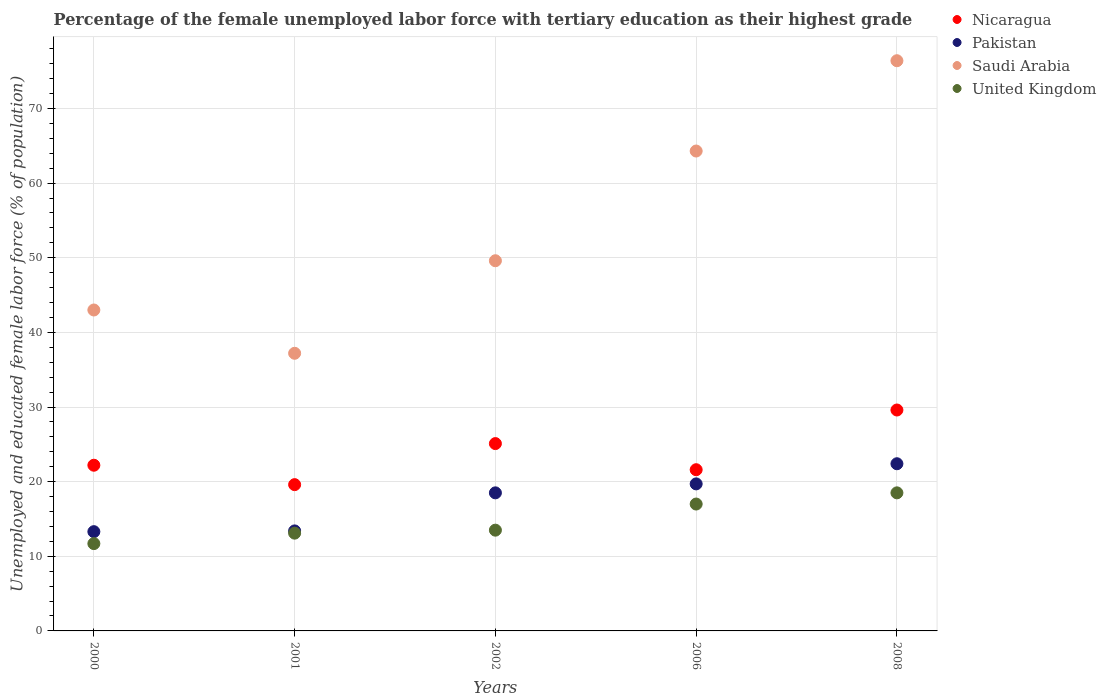How many different coloured dotlines are there?
Make the answer very short. 4. What is the percentage of the unemployed female labor force with tertiary education in Pakistan in 2002?
Your answer should be compact. 18.5. Across all years, what is the maximum percentage of the unemployed female labor force with tertiary education in Nicaragua?
Offer a terse response. 29.6. Across all years, what is the minimum percentage of the unemployed female labor force with tertiary education in Saudi Arabia?
Ensure brevity in your answer.  37.2. In which year was the percentage of the unemployed female labor force with tertiary education in Saudi Arabia maximum?
Give a very brief answer. 2008. What is the total percentage of the unemployed female labor force with tertiary education in United Kingdom in the graph?
Ensure brevity in your answer.  73.8. What is the difference between the percentage of the unemployed female labor force with tertiary education in Nicaragua in 2000 and that in 2002?
Your answer should be compact. -2.9. What is the difference between the percentage of the unemployed female labor force with tertiary education in United Kingdom in 2001 and the percentage of the unemployed female labor force with tertiary education in Saudi Arabia in 2000?
Make the answer very short. -29.9. What is the average percentage of the unemployed female labor force with tertiary education in Pakistan per year?
Offer a very short reply. 17.46. In the year 2000, what is the difference between the percentage of the unemployed female labor force with tertiary education in Saudi Arabia and percentage of the unemployed female labor force with tertiary education in Nicaragua?
Your answer should be compact. 20.8. In how many years, is the percentage of the unemployed female labor force with tertiary education in Saudi Arabia greater than 4 %?
Offer a terse response. 5. What is the ratio of the percentage of the unemployed female labor force with tertiary education in Nicaragua in 2006 to that in 2008?
Your answer should be compact. 0.73. Is the difference between the percentage of the unemployed female labor force with tertiary education in Saudi Arabia in 2002 and 2006 greater than the difference between the percentage of the unemployed female labor force with tertiary education in Nicaragua in 2002 and 2006?
Your answer should be very brief. No. What is the difference between the highest and the second highest percentage of the unemployed female labor force with tertiary education in Pakistan?
Keep it short and to the point. 2.7. What is the difference between the highest and the lowest percentage of the unemployed female labor force with tertiary education in Saudi Arabia?
Your response must be concise. 39.2. In how many years, is the percentage of the unemployed female labor force with tertiary education in Pakistan greater than the average percentage of the unemployed female labor force with tertiary education in Pakistan taken over all years?
Your answer should be very brief. 3. Is the sum of the percentage of the unemployed female labor force with tertiary education in United Kingdom in 2001 and 2008 greater than the maximum percentage of the unemployed female labor force with tertiary education in Pakistan across all years?
Make the answer very short. Yes. Is it the case that in every year, the sum of the percentage of the unemployed female labor force with tertiary education in Nicaragua and percentage of the unemployed female labor force with tertiary education in United Kingdom  is greater than the sum of percentage of the unemployed female labor force with tertiary education in Pakistan and percentage of the unemployed female labor force with tertiary education in Saudi Arabia?
Ensure brevity in your answer.  No. Is it the case that in every year, the sum of the percentage of the unemployed female labor force with tertiary education in Pakistan and percentage of the unemployed female labor force with tertiary education in Saudi Arabia  is greater than the percentage of the unemployed female labor force with tertiary education in United Kingdom?
Provide a short and direct response. Yes. Is the percentage of the unemployed female labor force with tertiary education in Pakistan strictly greater than the percentage of the unemployed female labor force with tertiary education in Nicaragua over the years?
Provide a short and direct response. No. Is the percentage of the unemployed female labor force with tertiary education in Saudi Arabia strictly less than the percentage of the unemployed female labor force with tertiary education in United Kingdom over the years?
Provide a short and direct response. No. How many dotlines are there?
Provide a succinct answer. 4. What is the difference between two consecutive major ticks on the Y-axis?
Ensure brevity in your answer.  10. Are the values on the major ticks of Y-axis written in scientific E-notation?
Keep it short and to the point. No. How are the legend labels stacked?
Provide a short and direct response. Vertical. What is the title of the graph?
Ensure brevity in your answer.  Percentage of the female unemployed labor force with tertiary education as their highest grade. What is the label or title of the X-axis?
Your answer should be compact. Years. What is the label or title of the Y-axis?
Your response must be concise. Unemployed and educated female labor force (% of population). What is the Unemployed and educated female labor force (% of population) in Nicaragua in 2000?
Provide a short and direct response. 22.2. What is the Unemployed and educated female labor force (% of population) of Pakistan in 2000?
Offer a terse response. 13.3. What is the Unemployed and educated female labor force (% of population) in United Kingdom in 2000?
Make the answer very short. 11.7. What is the Unemployed and educated female labor force (% of population) of Nicaragua in 2001?
Offer a very short reply. 19.6. What is the Unemployed and educated female labor force (% of population) of Pakistan in 2001?
Your answer should be very brief. 13.4. What is the Unemployed and educated female labor force (% of population) of Saudi Arabia in 2001?
Provide a succinct answer. 37.2. What is the Unemployed and educated female labor force (% of population) of United Kingdom in 2001?
Make the answer very short. 13.1. What is the Unemployed and educated female labor force (% of population) in Nicaragua in 2002?
Your answer should be compact. 25.1. What is the Unemployed and educated female labor force (% of population) of Saudi Arabia in 2002?
Your answer should be very brief. 49.6. What is the Unemployed and educated female labor force (% of population) of United Kingdom in 2002?
Provide a succinct answer. 13.5. What is the Unemployed and educated female labor force (% of population) in Nicaragua in 2006?
Offer a terse response. 21.6. What is the Unemployed and educated female labor force (% of population) in Pakistan in 2006?
Ensure brevity in your answer.  19.7. What is the Unemployed and educated female labor force (% of population) in Saudi Arabia in 2006?
Keep it short and to the point. 64.3. What is the Unemployed and educated female labor force (% of population) in Nicaragua in 2008?
Offer a terse response. 29.6. What is the Unemployed and educated female labor force (% of population) in Pakistan in 2008?
Your response must be concise. 22.4. What is the Unemployed and educated female labor force (% of population) of Saudi Arabia in 2008?
Your answer should be compact. 76.4. What is the Unemployed and educated female labor force (% of population) in United Kingdom in 2008?
Ensure brevity in your answer.  18.5. Across all years, what is the maximum Unemployed and educated female labor force (% of population) in Nicaragua?
Provide a succinct answer. 29.6. Across all years, what is the maximum Unemployed and educated female labor force (% of population) in Pakistan?
Provide a short and direct response. 22.4. Across all years, what is the maximum Unemployed and educated female labor force (% of population) of Saudi Arabia?
Offer a terse response. 76.4. Across all years, what is the maximum Unemployed and educated female labor force (% of population) in United Kingdom?
Give a very brief answer. 18.5. Across all years, what is the minimum Unemployed and educated female labor force (% of population) of Nicaragua?
Offer a terse response. 19.6. Across all years, what is the minimum Unemployed and educated female labor force (% of population) in Pakistan?
Make the answer very short. 13.3. Across all years, what is the minimum Unemployed and educated female labor force (% of population) of Saudi Arabia?
Give a very brief answer. 37.2. Across all years, what is the minimum Unemployed and educated female labor force (% of population) in United Kingdom?
Provide a short and direct response. 11.7. What is the total Unemployed and educated female labor force (% of population) in Nicaragua in the graph?
Your answer should be very brief. 118.1. What is the total Unemployed and educated female labor force (% of population) in Pakistan in the graph?
Keep it short and to the point. 87.3. What is the total Unemployed and educated female labor force (% of population) in Saudi Arabia in the graph?
Offer a terse response. 270.5. What is the total Unemployed and educated female labor force (% of population) in United Kingdom in the graph?
Offer a very short reply. 73.8. What is the difference between the Unemployed and educated female labor force (% of population) in Nicaragua in 2000 and that in 2001?
Your response must be concise. 2.6. What is the difference between the Unemployed and educated female labor force (% of population) in Pakistan in 2000 and that in 2001?
Offer a very short reply. -0.1. What is the difference between the Unemployed and educated female labor force (% of population) of Saudi Arabia in 2000 and that in 2001?
Provide a short and direct response. 5.8. What is the difference between the Unemployed and educated female labor force (% of population) in Nicaragua in 2000 and that in 2002?
Give a very brief answer. -2.9. What is the difference between the Unemployed and educated female labor force (% of population) of Saudi Arabia in 2000 and that in 2002?
Provide a succinct answer. -6.6. What is the difference between the Unemployed and educated female labor force (% of population) of United Kingdom in 2000 and that in 2002?
Make the answer very short. -1.8. What is the difference between the Unemployed and educated female labor force (% of population) of Saudi Arabia in 2000 and that in 2006?
Provide a succinct answer. -21.3. What is the difference between the Unemployed and educated female labor force (% of population) in Nicaragua in 2000 and that in 2008?
Ensure brevity in your answer.  -7.4. What is the difference between the Unemployed and educated female labor force (% of population) of Saudi Arabia in 2000 and that in 2008?
Make the answer very short. -33.4. What is the difference between the Unemployed and educated female labor force (% of population) of Pakistan in 2001 and that in 2002?
Keep it short and to the point. -5.1. What is the difference between the Unemployed and educated female labor force (% of population) in Pakistan in 2001 and that in 2006?
Provide a short and direct response. -6.3. What is the difference between the Unemployed and educated female labor force (% of population) in Saudi Arabia in 2001 and that in 2006?
Give a very brief answer. -27.1. What is the difference between the Unemployed and educated female labor force (% of population) of Pakistan in 2001 and that in 2008?
Provide a succinct answer. -9. What is the difference between the Unemployed and educated female labor force (% of population) of Saudi Arabia in 2001 and that in 2008?
Your response must be concise. -39.2. What is the difference between the Unemployed and educated female labor force (% of population) in Nicaragua in 2002 and that in 2006?
Your answer should be very brief. 3.5. What is the difference between the Unemployed and educated female labor force (% of population) of Pakistan in 2002 and that in 2006?
Give a very brief answer. -1.2. What is the difference between the Unemployed and educated female labor force (% of population) of Saudi Arabia in 2002 and that in 2006?
Your response must be concise. -14.7. What is the difference between the Unemployed and educated female labor force (% of population) of Nicaragua in 2002 and that in 2008?
Provide a succinct answer. -4.5. What is the difference between the Unemployed and educated female labor force (% of population) of Saudi Arabia in 2002 and that in 2008?
Offer a very short reply. -26.8. What is the difference between the Unemployed and educated female labor force (% of population) in Nicaragua in 2000 and the Unemployed and educated female labor force (% of population) in Pakistan in 2001?
Make the answer very short. 8.8. What is the difference between the Unemployed and educated female labor force (% of population) of Nicaragua in 2000 and the Unemployed and educated female labor force (% of population) of United Kingdom in 2001?
Provide a succinct answer. 9.1. What is the difference between the Unemployed and educated female labor force (% of population) of Pakistan in 2000 and the Unemployed and educated female labor force (% of population) of Saudi Arabia in 2001?
Offer a very short reply. -23.9. What is the difference between the Unemployed and educated female labor force (% of population) in Pakistan in 2000 and the Unemployed and educated female labor force (% of population) in United Kingdom in 2001?
Your answer should be very brief. 0.2. What is the difference between the Unemployed and educated female labor force (% of population) in Saudi Arabia in 2000 and the Unemployed and educated female labor force (% of population) in United Kingdom in 2001?
Keep it short and to the point. 29.9. What is the difference between the Unemployed and educated female labor force (% of population) in Nicaragua in 2000 and the Unemployed and educated female labor force (% of population) in Saudi Arabia in 2002?
Provide a succinct answer. -27.4. What is the difference between the Unemployed and educated female labor force (% of population) in Nicaragua in 2000 and the Unemployed and educated female labor force (% of population) in United Kingdom in 2002?
Make the answer very short. 8.7. What is the difference between the Unemployed and educated female labor force (% of population) of Pakistan in 2000 and the Unemployed and educated female labor force (% of population) of Saudi Arabia in 2002?
Ensure brevity in your answer.  -36.3. What is the difference between the Unemployed and educated female labor force (% of population) of Pakistan in 2000 and the Unemployed and educated female labor force (% of population) of United Kingdom in 2002?
Offer a terse response. -0.2. What is the difference between the Unemployed and educated female labor force (% of population) of Saudi Arabia in 2000 and the Unemployed and educated female labor force (% of population) of United Kingdom in 2002?
Keep it short and to the point. 29.5. What is the difference between the Unemployed and educated female labor force (% of population) of Nicaragua in 2000 and the Unemployed and educated female labor force (% of population) of Saudi Arabia in 2006?
Offer a very short reply. -42.1. What is the difference between the Unemployed and educated female labor force (% of population) of Nicaragua in 2000 and the Unemployed and educated female labor force (% of population) of United Kingdom in 2006?
Make the answer very short. 5.2. What is the difference between the Unemployed and educated female labor force (% of population) of Pakistan in 2000 and the Unemployed and educated female labor force (% of population) of Saudi Arabia in 2006?
Your answer should be very brief. -51. What is the difference between the Unemployed and educated female labor force (% of population) of Nicaragua in 2000 and the Unemployed and educated female labor force (% of population) of Saudi Arabia in 2008?
Keep it short and to the point. -54.2. What is the difference between the Unemployed and educated female labor force (% of population) of Nicaragua in 2000 and the Unemployed and educated female labor force (% of population) of United Kingdom in 2008?
Make the answer very short. 3.7. What is the difference between the Unemployed and educated female labor force (% of population) in Pakistan in 2000 and the Unemployed and educated female labor force (% of population) in Saudi Arabia in 2008?
Offer a terse response. -63.1. What is the difference between the Unemployed and educated female labor force (% of population) of Saudi Arabia in 2000 and the Unemployed and educated female labor force (% of population) of United Kingdom in 2008?
Your response must be concise. 24.5. What is the difference between the Unemployed and educated female labor force (% of population) of Nicaragua in 2001 and the Unemployed and educated female labor force (% of population) of Saudi Arabia in 2002?
Ensure brevity in your answer.  -30. What is the difference between the Unemployed and educated female labor force (% of population) in Nicaragua in 2001 and the Unemployed and educated female labor force (% of population) in United Kingdom in 2002?
Offer a terse response. 6.1. What is the difference between the Unemployed and educated female labor force (% of population) in Pakistan in 2001 and the Unemployed and educated female labor force (% of population) in Saudi Arabia in 2002?
Give a very brief answer. -36.2. What is the difference between the Unemployed and educated female labor force (% of population) of Saudi Arabia in 2001 and the Unemployed and educated female labor force (% of population) of United Kingdom in 2002?
Give a very brief answer. 23.7. What is the difference between the Unemployed and educated female labor force (% of population) of Nicaragua in 2001 and the Unemployed and educated female labor force (% of population) of Pakistan in 2006?
Your response must be concise. -0.1. What is the difference between the Unemployed and educated female labor force (% of population) of Nicaragua in 2001 and the Unemployed and educated female labor force (% of population) of Saudi Arabia in 2006?
Your answer should be very brief. -44.7. What is the difference between the Unemployed and educated female labor force (% of population) of Pakistan in 2001 and the Unemployed and educated female labor force (% of population) of Saudi Arabia in 2006?
Your answer should be compact. -50.9. What is the difference between the Unemployed and educated female labor force (% of population) in Pakistan in 2001 and the Unemployed and educated female labor force (% of population) in United Kingdom in 2006?
Your answer should be very brief. -3.6. What is the difference between the Unemployed and educated female labor force (% of population) in Saudi Arabia in 2001 and the Unemployed and educated female labor force (% of population) in United Kingdom in 2006?
Provide a short and direct response. 20.2. What is the difference between the Unemployed and educated female labor force (% of population) in Nicaragua in 2001 and the Unemployed and educated female labor force (% of population) in Saudi Arabia in 2008?
Provide a short and direct response. -56.8. What is the difference between the Unemployed and educated female labor force (% of population) of Pakistan in 2001 and the Unemployed and educated female labor force (% of population) of Saudi Arabia in 2008?
Offer a very short reply. -63. What is the difference between the Unemployed and educated female labor force (% of population) in Nicaragua in 2002 and the Unemployed and educated female labor force (% of population) in Saudi Arabia in 2006?
Provide a succinct answer. -39.2. What is the difference between the Unemployed and educated female labor force (% of population) of Pakistan in 2002 and the Unemployed and educated female labor force (% of population) of Saudi Arabia in 2006?
Ensure brevity in your answer.  -45.8. What is the difference between the Unemployed and educated female labor force (% of population) of Saudi Arabia in 2002 and the Unemployed and educated female labor force (% of population) of United Kingdom in 2006?
Make the answer very short. 32.6. What is the difference between the Unemployed and educated female labor force (% of population) in Nicaragua in 2002 and the Unemployed and educated female labor force (% of population) in Saudi Arabia in 2008?
Offer a very short reply. -51.3. What is the difference between the Unemployed and educated female labor force (% of population) of Nicaragua in 2002 and the Unemployed and educated female labor force (% of population) of United Kingdom in 2008?
Offer a very short reply. 6.6. What is the difference between the Unemployed and educated female labor force (% of population) of Pakistan in 2002 and the Unemployed and educated female labor force (% of population) of Saudi Arabia in 2008?
Offer a very short reply. -57.9. What is the difference between the Unemployed and educated female labor force (% of population) in Pakistan in 2002 and the Unemployed and educated female labor force (% of population) in United Kingdom in 2008?
Keep it short and to the point. 0. What is the difference between the Unemployed and educated female labor force (% of population) of Saudi Arabia in 2002 and the Unemployed and educated female labor force (% of population) of United Kingdom in 2008?
Offer a terse response. 31.1. What is the difference between the Unemployed and educated female labor force (% of population) of Nicaragua in 2006 and the Unemployed and educated female labor force (% of population) of Pakistan in 2008?
Keep it short and to the point. -0.8. What is the difference between the Unemployed and educated female labor force (% of population) in Nicaragua in 2006 and the Unemployed and educated female labor force (% of population) in Saudi Arabia in 2008?
Your answer should be compact. -54.8. What is the difference between the Unemployed and educated female labor force (% of population) in Pakistan in 2006 and the Unemployed and educated female labor force (% of population) in Saudi Arabia in 2008?
Give a very brief answer. -56.7. What is the difference between the Unemployed and educated female labor force (% of population) of Pakistan in 2006 and the Unemployed and educated female labor force (% of population) of United Kingdom in 2008?
Provide a short and direct response. 1.2. What is the difference between the Unemployed and educated female labor force (% of population) of Saudi Arabia in 2006 and the Unemployed and educated female labor force (% of population) of United Kingdom in 2008?
Offer a very short reply. 45.8. What is the average Unemployed and educated female labor force (% of population) in Nicaragua per year?
Your answer should be very brief. 23.62. What is the average Unemployed and educated female labor force (% of population) of Pakistan per year?
Give a very brief answer. 17.46. What is the average Unemployed and educated female labor force (% of population) in Saudi Arabia per year?
Your answer should be compact. 54.1. What is the average Unemployed and educated female labor force (% of population) of United Kingdom per year?
Offer a very short reply. 14.76. In the year 2000, what is the difference between the Unemployed and educated female labor force (% of population) of Nicaragua and Unemployed and educated female labor force (% of population) of Pakistan?
Ensure brevity in your answer.  8.9. In the year 2000, what is the difference between the Unemployed and educated female labor force (% of population) in Nicaragua and Unemployed and educated female labor force (% of population) in Saudi Arabia?
Offer a very short reply. -20.8. In the year 2000, what is the difference between the Unemployed and educated female labor force (% of population) in Nicaragua and Unemployed and educated female labor force (% of population) in United Kingdom?
Keep it short and to the point. 10.5. In the year 2000, what is the difference between the Unemployed and educated female labor force (% of population) in Pakistan and Unemployed and educated female labor force (% of population) in Saudi Arabia?
Your answer should be compact. -29.7. In the year 2000, what is the difference between the Unemployed and educated female labor force (% of population) of Saudi Arabia and Unemployed and educated female labor force (% of population) of United Kingdom?
Keep it short and to the point. 31.3. In the year 2001, what is the difference between the Unemployed and educated female labor force (% of population) in Nicaragua and Unemployed and educated female labor force (% of population) in Pakistan?
Your response must be concise. 6.2. In the year 2001, what is the difference between the Unemployed and educated female labor force (% of population) of Nicaragua and Unemployed and educated female labor force (% of population) of Saudi Arabia?
Ensure brevity in your answer.  -17.6. In the year 2001, what is the difference between the Unemployed and educated female labor force (% of population) in Pakistan and Unemployed and educated female labor force (% of population) in Saudi Arabia?
Provide a short and direct response. -23.8. In the year 2001, what is the difference between the Unemployed and educated female labor force (% of population) of Saudi Arabia and Unemployed and educated female labor force (% of population) of United Kingdom?
Ensure brevity in your answer.  24.1. In the year 2002, what is the difference between the Unemployed and educated female labor force (% of population) of Nicaragua and Unemployed and educated female labor force (% of population) of Saudi Arabia?
Your response must be concise. -24.5. In the year 2002, what is the difference between the Unemployed and educated female labor force (% of population) in Nicaragua and Unemployed and educated female labor force (% of population) in United Kingdom?
Offer a terse response. 11.6. In the year 2002, what is the difference between the Unemployed and educated female labor force (% of population) in Pakistan and Unemployed and educated female labor force (% of population) in Saudi Arabia?
Your answer should be very brief. -31.1. In the year 2002, what is the difference between the Unemployed and educated female labor force (% of population) of Pakistan and Unemployed and educated female labor force (% of population) of United Kingdom?
Provide a succinct answer. 5. In the year 2002, what is the difference between the Unemployed and educated female labor force (% of population) of Saudi Arabia and Unemployed and educated female labor force (% of population) of United Kingdom?
Offer a very short reply. 36.1. In the year 2006, what is the difference between the Unemployed and educated female labor force (% of population) of Nicaragua and Unemployed and educated female labor force (% of population) of Saudi Arabia?
Give a very brief answer. -42.7. In the year 2006, what is the difference between the Unemployed and educated female labor force (% of population) in Pakistan and Unemployed and educated female labor force (% of population) in Saudi Arabia?
Your answer should be very brief. -44.6. In the year 2006, what is the difference between the Unemployed and educated female labor force (% of population) in Pakistan and Unemployed and educated female labor force (% of population) in United Kingdom?
Offer a very short reply. 2.7. In the year 2006, what is the difference between the Unemployed and educated female labor force (% of population) of Saudi Arabia and Unemployed and educated female labor force (% of population) of United Kingdom?
Keep it short and to the point. 47.3. In the year 2008, what is the difference between the Unemployed and educated female labor force (% of population) in Nicaragua and Unemployed and educated female labor force (% of population) in Pakistan?
Your response must be concise. 7.2. In the year 2008, what is the difference between the Unemployed and educated female labor force (% of population) of Nicaragua and Unemployed and educated female labor force (% of population) of Saudi Arabia?
Offer a very short reply. -46.8. In the year 2008, what is the difference between the Unemployed and educated female labor force (% of population) of Nicaragua and Unemployed and educated female labor force (% of population) of United Kingdom?
Offer a very short reply. 11.1. In the year 2008, what is the difference between the Unemployed and educated female labor force (% of population) in Pakistan and Unemployed and educated female labor force (% of population) in Saudi Arabia?
Make the answer very short. -54. In the year 2008, what is the difference between the Unemployed and educated female labor force (% of population) in Pakistan and Unemployed and educated female labor force (% of population) in United Kingdom?
Keep it short and to the point. 3.9. In the year 2008, what is the difference between the Unemployed and educated female labor force (% of population) of Saudi Arabia and Unemployed and educated female labor force (% of population) of United Kingdom?
Provide a succinct answer. 57.9. What is the ratio of the Unemployed and educated female labor force (% of population) of Nicaragua in 2000 to that in 2001?
Keep it short and to the point. 1.13. What is the ratio of the Unemployed and educated female labor force (% of population) in Pakistan in 2000 to that in 2001?
Ensure brevity in your answer.  0.99. What is the ratio of the Unemployed and educated female labor force (% of population) of Saudi Arabia in 2000 to that in 2001?
Your answer should be very brief. 1.16. What is the ratio of the Unemployed and educated female labor force (% of population) in United Kingdom in 2000 to that in 2001?
Give a very brief answer. 0.89. What is the ratio of the Unemployed and educated female labor force (% of population) in Nicaragua in 2000 to that in 2002?
Make the answer very short. 0.88. What is the ratio of the Unemployed and educated female labor force (% of population) of Pakistan in 2000 to that in 2002?
Your answer should be compact. 0.72. What is the ratio of the Unemployed and educated female labor force (% of population) in Saudi Arabia in 2000 to that in 2002?
Provide a succinct answer. 0.87. What is the ratio of the Unemployed and educated female labor force (% of population) in United Kingdom in 2000 to that in 2002?
Offer a terse response. 0.87. What is the ratio of the Unemployed and educated female labor force (% of population) in Nicaragua in 2000 to that in 2006?
Provide a short and direct response. 1.03. What is the ratio of the Unemployed and educated female labor force (% of population) of Pakistan in 2000 to that in 2006?
Ensure brevity in your answer.  0.68. What is the ratio of the Unemployed and educated female labor force (% of population) of Saudi Arabia in 2000 to that in 2006?
Give a very brief answer. 0.67. What is the ratio of the Unemployed and educated female labor force (% of population) in United Kingdom in 2000 to that in 2006?
Make the answer very short. 0.69. What is the ratio of the Unemployed and educated female labor force (% of population) of Nicaragua in 2000 to that in 2008?
Offer a very short reply. 0.75. What is the ratio of the Unemployed and educated female labor force (% of population) in Pakistan in 2000 to that in 2008?
Your answer should be compact. 0.59. What is the ratio of the Unemployed and educated female labor force (% of population) in Saudi Arabia in 2000 to that in 2008?
Provide a succinct answer. 0.56. What is the ratio of the Unemployed and educated female labor force (% of population) in United Kingdom in 2000 to that in 2008?
Provide a short and direct response. 0.63. What is the ratio of the Unemployed and educated female labor force (% of population) in Nicaragua in 2001 to that in 2002?
Make the answer very short. 0.78. What is the ratio of the Unemployed and educated female labor force (% of population) of Pakistan in 2001 to that in 2002?
Offer a very short reply. 0.72. What is the ratio of the Unemployed and educated female labor force (% of population) in Saudi Arabia in 2001 to that in 2002?
Your answer should be compact. 0.75. What is the ratio of the Unemployed and educated female labor force (% of population) of United Kingdom in 2001 to that in 2002?
Your answer should be compact. 0.97. What is the ratio of the Unemployed and educated female labor force (% of population) of Nicaragua in 2001 to that in 2006?
Your answer should be compact. 0.91. What is the ratio of the Unemployed and educated female labor force (% of population) of Pakistan in 2001 to that in 2006?
Make the answer very short. 0.68. What is the ratio of the Unemployed and educated female labor force (% of population) in Saudi Arabia in 2001 to that in 2006?
Provide a short and direct response. 0.58. What is the ratio of the Unemployed and educated female labor force (% of population) in United Kingdom in 2001 to that in 2006?
Make the answer very short. 0.77. What is the ratio of the Unemployed and educated female labor force (% of population) of Nicaragua in 2001 to that in 2008?
Your answer should be very brief. 0.66. What is the ratio of the Unemployed and educated female labor force (% of population) of Pakistan in 2001 to that in 2008?
Your answer should be compact. 0.6. What is the ratio of the Unemployed and educated female labor force (% of population) in Saudi Arabia in 2001 to that in 2008?
Offer a very short reply. 0.49. What is the ratio of the Unemployed and educated female labor force (% of population) of United Kingdom in 2001 to that in 2008?
Your response must be concise. 0.71. What is the ratio of the Unemployed and educated female labor force (% of population) of Nicaragua in 2002 to that in 2006?
Offer a terse response. 1.16. What is the ratio of the Unemployed and educated female labor force (% of population) of Pakistan in 2002 to that in 2006?
Provide a succinct answer. 0.94. What is the ratio of the Unemployed and educated female labor force (% of population) in Saudi Arabia in 2002 to that in 2006?
Your response must be concise. 0.77. What is the ratio of the Unemployed and educated female labor force (% of population) in United Kingdom in 2002 to that in 2006?
Give a very brief answer. 0.79. What is the ratio of the Unemployed and educated female labor force (% of population) of Nicaragua in 2002 to that in 2008?
Provide a succinct answer. 0.85. What is the ratio of the Unemployed and educated female labor force (% of population) in Pakistan in 2002 to that in 2008?
Give a very brief answer. 0.83. What is the ratio of the Unemployed and educated female labor force (% of population) in Saudi Arabia in 2002 to that in 2008?
Make the answer very short. 0.65. What is the ratio of the Unemployed and educated female labor force (% of population) of United Kingdom in 2002 to that in 2008?
Keep it short and to the point. 0.73. What is the ratio of the Unemployed and educated female labor force (% of population) in Nicaragua in 2006 to that in 2008?
Your answer should be compact. 0.73. What is the ratio of the Unemployed and educated female labor force (% of population) in Pakistan in 2006 to that in 2008?
Your response must be concise. 0.88. What is the ratio of the Unemployed and educated female labor force (% of population) of Saudi Arabia in 2006 to that in 2008?
Your answer should be very brief. 0.84. What is the ratio of the Unemployed and educated female labor force (% of population) in United Kingdom in 2006 to that in 2008?
Your response must be concise. 0.92. What is the difference between the highest and the second highest Unemployed and educated female labor force (% of population) in Nicaragua?
Ensure brevity in your answer.  4.5. What is the difference between the highest and the second highest Unemployed and educated female labor force (% of population) of United Kingdom?
Your answer should be compact. 1.5. What is the difference between the highest and the lowest Unemployed and educated female labor force (% of population) in Saudi Arabia?
Offer a very short reply. 39.2. 